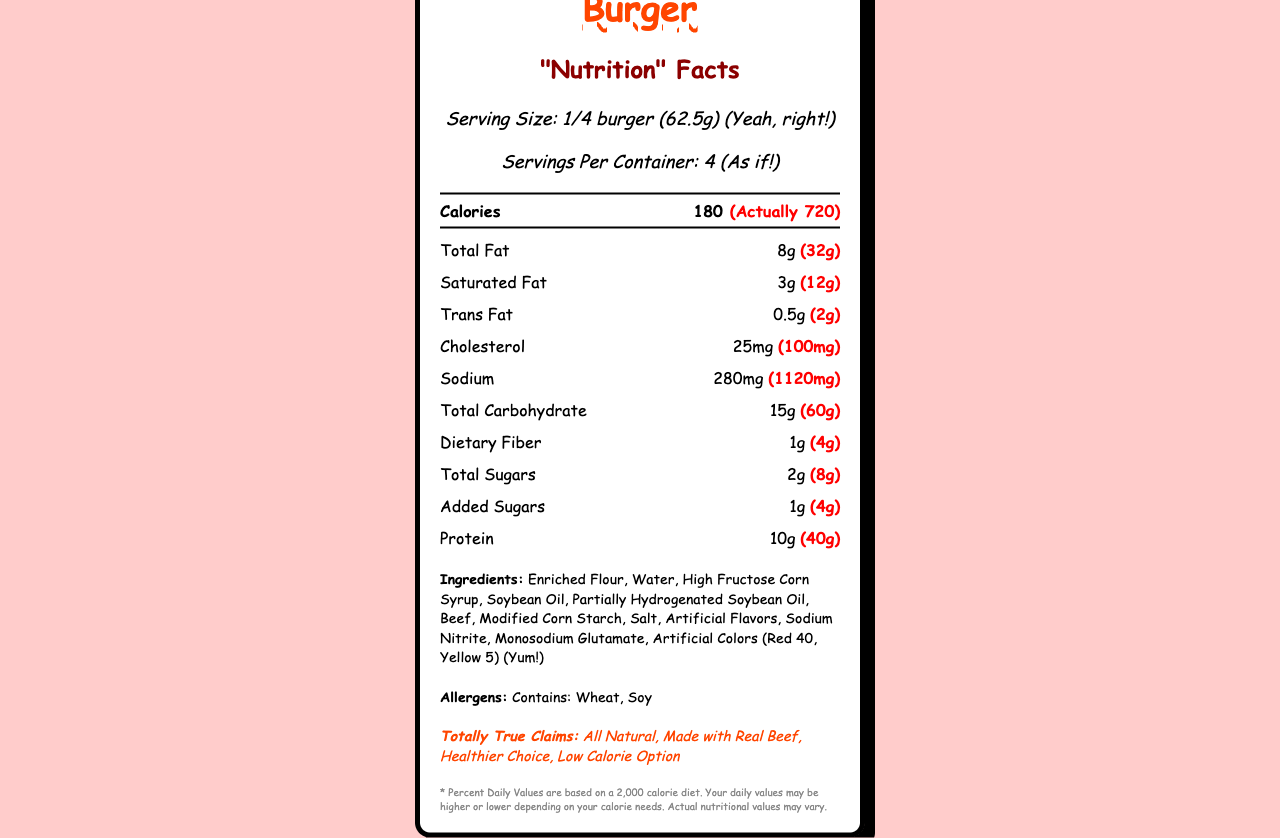how many servings are in the container? The label states that there are "Servings Per Container: 4."
Answer: 4 what is the serving size? The label specifies the serving size as "1/4 burger (62.5g)."
Answer: 1/4 burger (62.5g) how many calories are in one serving of McGreedy's Mega Burger? The label indicates the calories per serving as "180."
Answer: 180 calories how much actual sodium is in one burger? The label shows actual sodium per burger as "(1120mg)."
Answer: 1120mg what are the allergens listed in the ingredients? The allergens section indicates "Contains: Wheat, Soy."
Answer: Wheat, Soy what percentage of daily value does the actual total fat content represent? A. 20% B. 30% C. 41% D. 50% The label states the daily value percentage for total fat per serving is 41%, and since the actual amounts are four times those servings, it will be 164% which is not directly visible but we'll base on per-serving value.
Answer: C which misleading claim is made about this burger? I. All Natural II. Made with Real Beef III. Healthier Choice IV. Low Calorie Option The claims section lists "All Natural," "Made with Real Beef," "Healthier Choice," and "Low Calorie Option."
Answer: All of the above does the nutrition label claim this burger as a healthier choice? The label lists "Healthier Choice" under totally true claims.
Answer: Yes describe the main idea of the document? The document provides details on serving sizes, nutrient content, claims of health benefits, and ingredients for McGreedy’s Mega Burger. Notably, it points out the misleading nature of the provided nutritional values and claims.
Answer: The document is a nutrition facts label for McGreedy's Mega Burger that highlights both the exaggerated and deceptive claims about the product's health benefits. It also shows the actual and misleading serving sizes and nutritional information per serving and per actual amount. does this label specify how much Vitamin D is in the burger? The label specifies "Vitamin D: 0mcg."
Answer: Yes, it says 0mcg. what are the artificial colors used in the ingredients? The ingredients section lists the artificial colors as "Red 40, Yellow 5."
Answer: Red 40, Yellow 5 what foods should this burger's consumers avoid if they have a soy allergy? The document lists that the burger contains soy but does not provide information about other foods the consumer should avoid.
Answer: Cannot be determined 